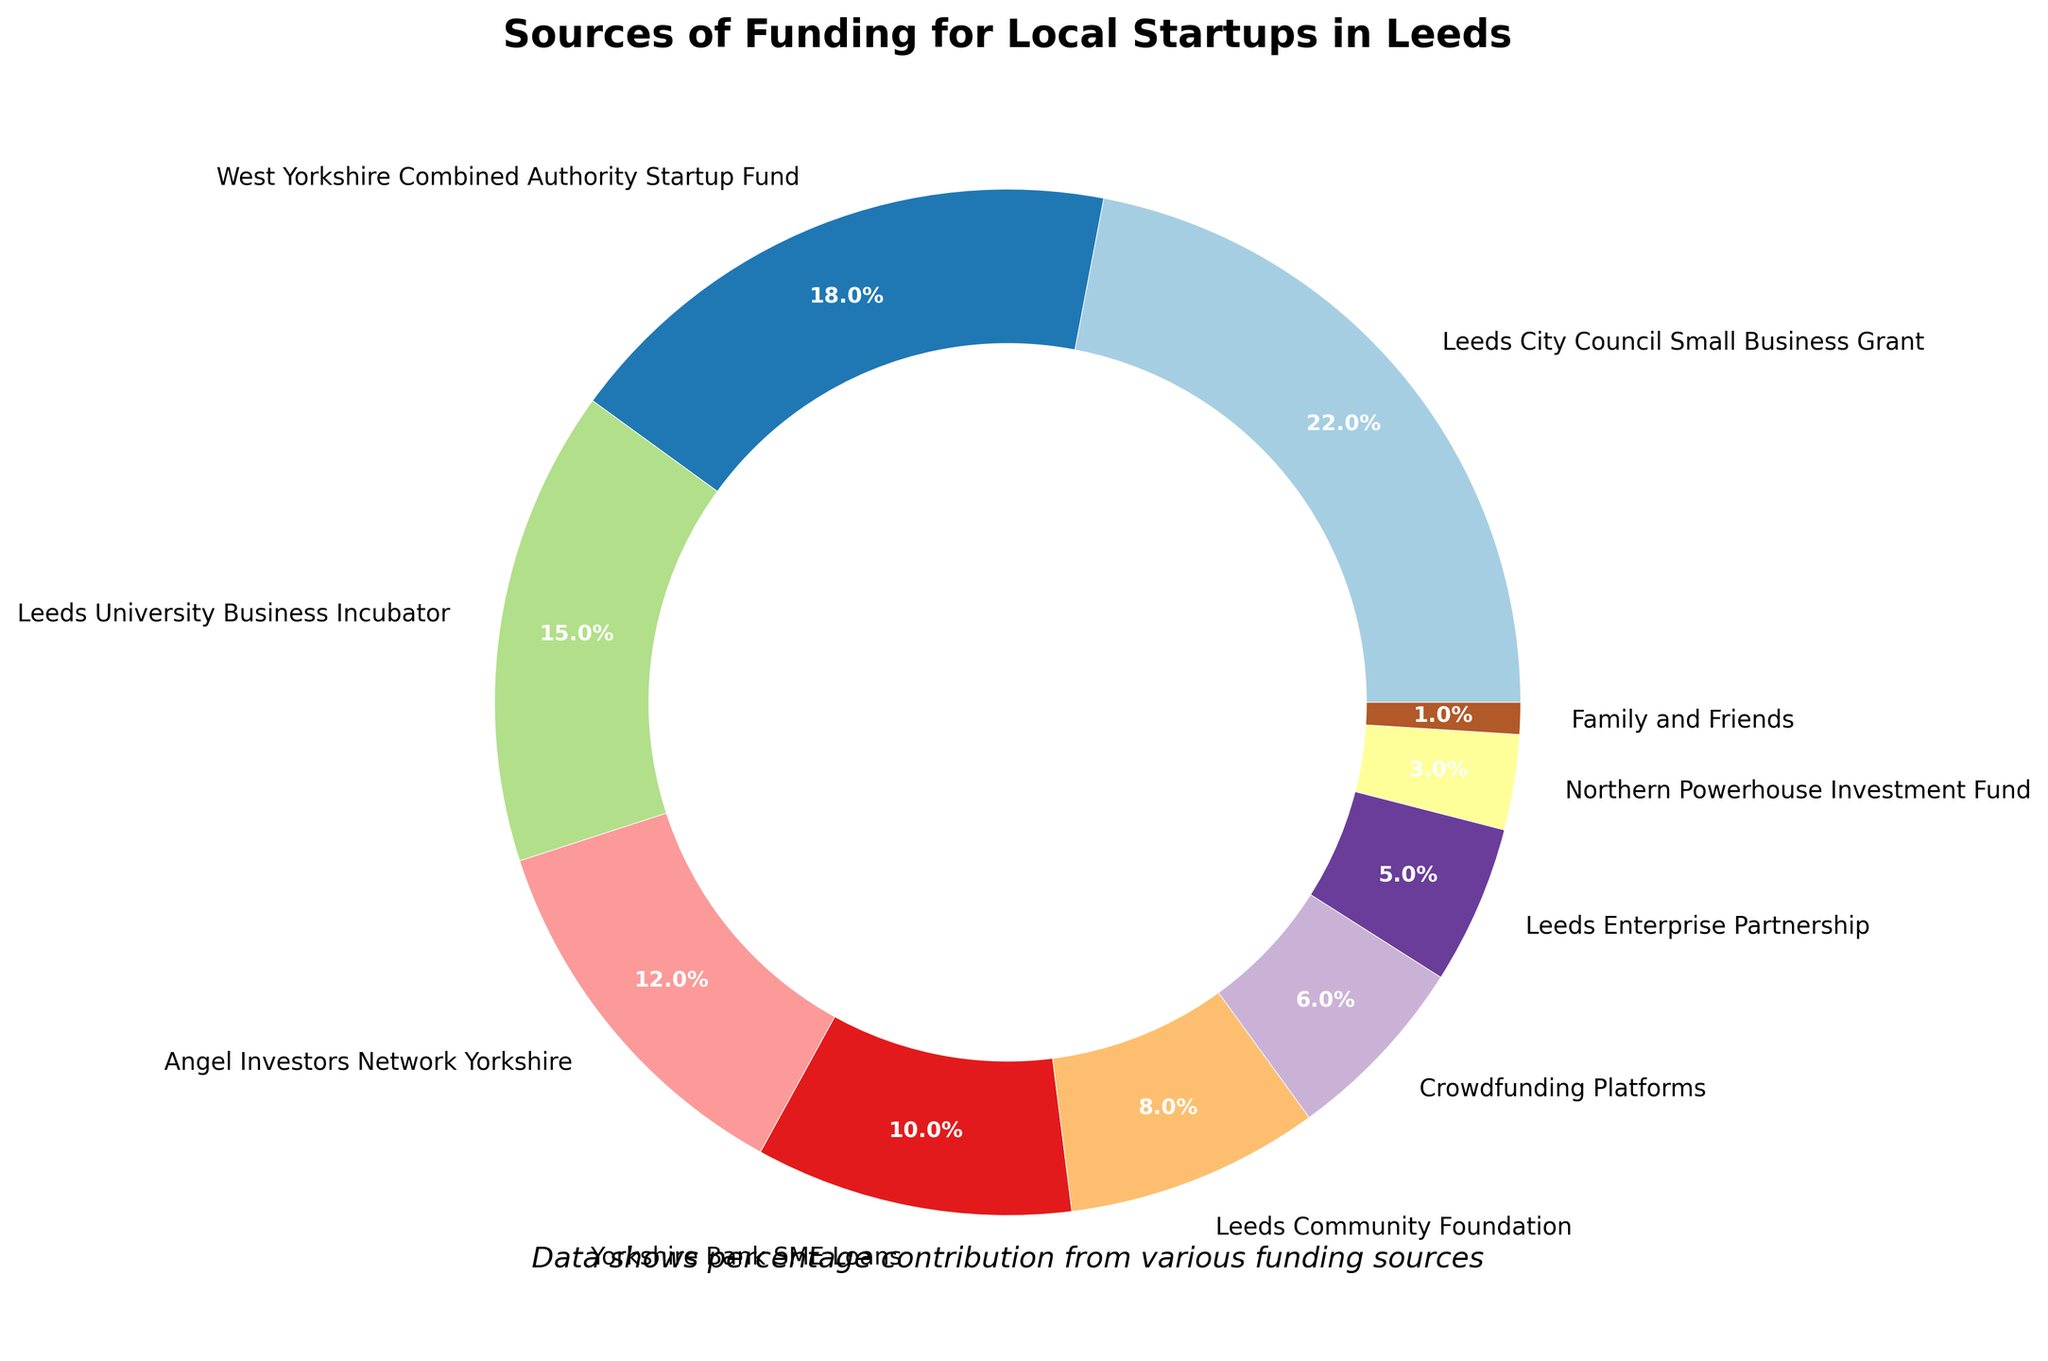What's the combined percentage of funding from Leeds City Council Small Business Grant and West Yorkshire Combined Authority Startup Fund? The Leeds City Council Small Business Grant is 22% and the West Yorkshire Combined Authority Startup Fund is 18%. Adding these together: 22% + 18% = 40%
Answer: 40% Which funding source provides the least amount of funding? The smallest segment on the pie chart corresponds to Family and Friends, which is labeled as 1%.
Answer: Family and Friends How much larger is the funding percentage of Leeds City Council Small Business Grant compared to Leeds Community Foundation? The Leeds City Council Small Business Grant is 22% while the Leeds Community Foundation is 8%. The difference between them is 22% - 8% = 14%.
Answer: 14% What is the difference in funding percentage between Leeds University Business Incubator and Angel Investors Network Yorkshire? The Leeds University Business Incubator is 15% and the Angel Investors Network Yorkshire is 12%. The difference is 15% - 12% = 3%.
Answer: 3% Which two funding sources together contribute to exactly 21% of the total funding? The pie chart shows Leeds Enterprise Partnership at 5% and Crowdfunding Platforms at 6%. Adding these: 5% + 6% = 11%. The next possible combination is Northern Powerhouse Investment Fund at 3% and Crowdfunding Platforms at 6%: 3% + 6% = 9%. The correct combination is Northern Powerhouse Investment Fund at 3% and Angel Investors Network Yorkshire at 18%: 3% + 18% = 21%.
Answer: Northern Powerhouse Investment Fund and Angel Investors Network Yorkshire Which funding source has a proportion around three times that of Leeds Community Foundation? The Leeds Community Foundation contributes 8% of the total funding. The Leeds City Council Small Business Grant contributes three times this percentage, which is approximately 8% * 3 = 24%. Checking the values, Leeds City Council Small Business Grant is 22%, which is close to three times 8%.
Answer: Leeds City Council Small Business Grant Which color segment is representing the Yorkshire Bank SME Loans on the chart? By visually inspecting the pie chart, Yorkshire Bank SME Loans is colored with a distinctive shade in the pie slices. The specific color details are embedded visually and Yorkshire Bank SME Loans can be observed marked in its color, around 10% from the top segments.
Answer: Varies by visualization (specific segment color can be identified by relative segment size of 10%) What is the average funding percentage of the three largest sources of funding? The three largest sources of funding are Leeds City Council Small Business Grant (22%), West Yorkshire Combined Authority Startup Fund (18%), and Leeds University Business Incubator (15%). Calculate the average: (22% + 18% + 15%) / 3 = 55% / 3 ≈ 18.33%.
Answer: 18.33% Does any single source account for more than half of the total funding? Looking at the largest percentage, Leeds City Council Small Business Grant, which is 22%, no single source accounts for more than half of the total funding, as 22% is less than 50%.
Answer: No 